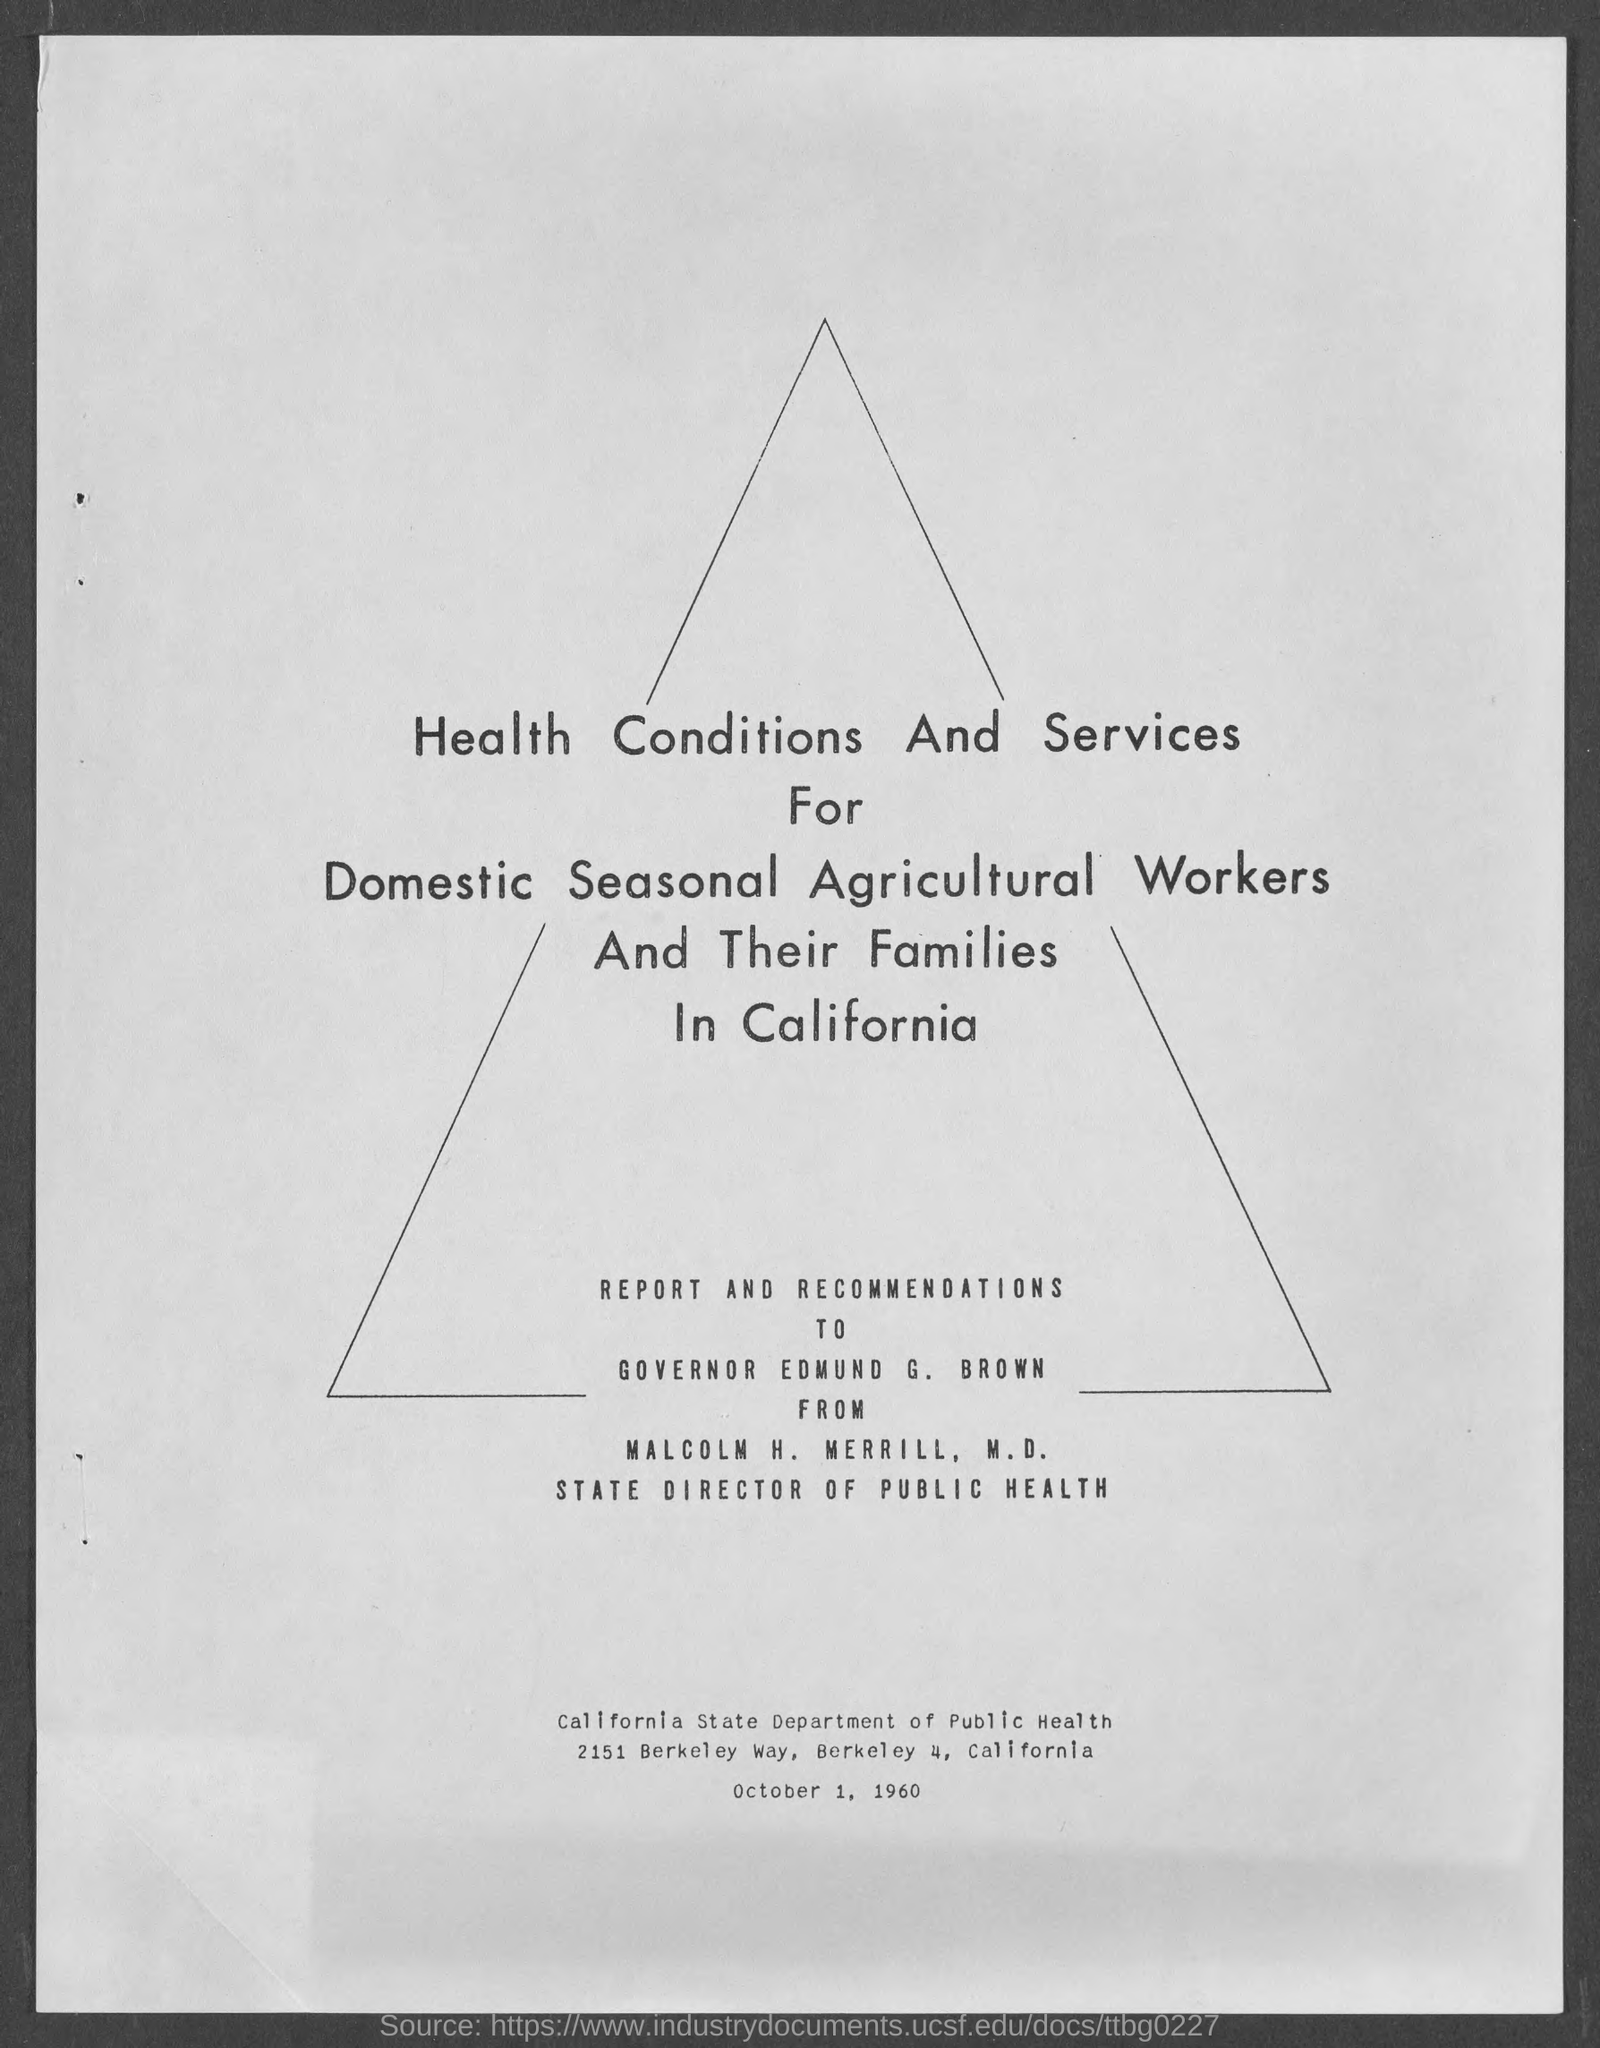Draw attention to some important aspects in this diagram. As of my knowledge cutoff date of September 2021, Edmund G. Brown held the position of Governor. The report and recommendations are presented to Edmund G. Brown. The individual named Malcolm H. Merrill is the State Director of Public Health. 